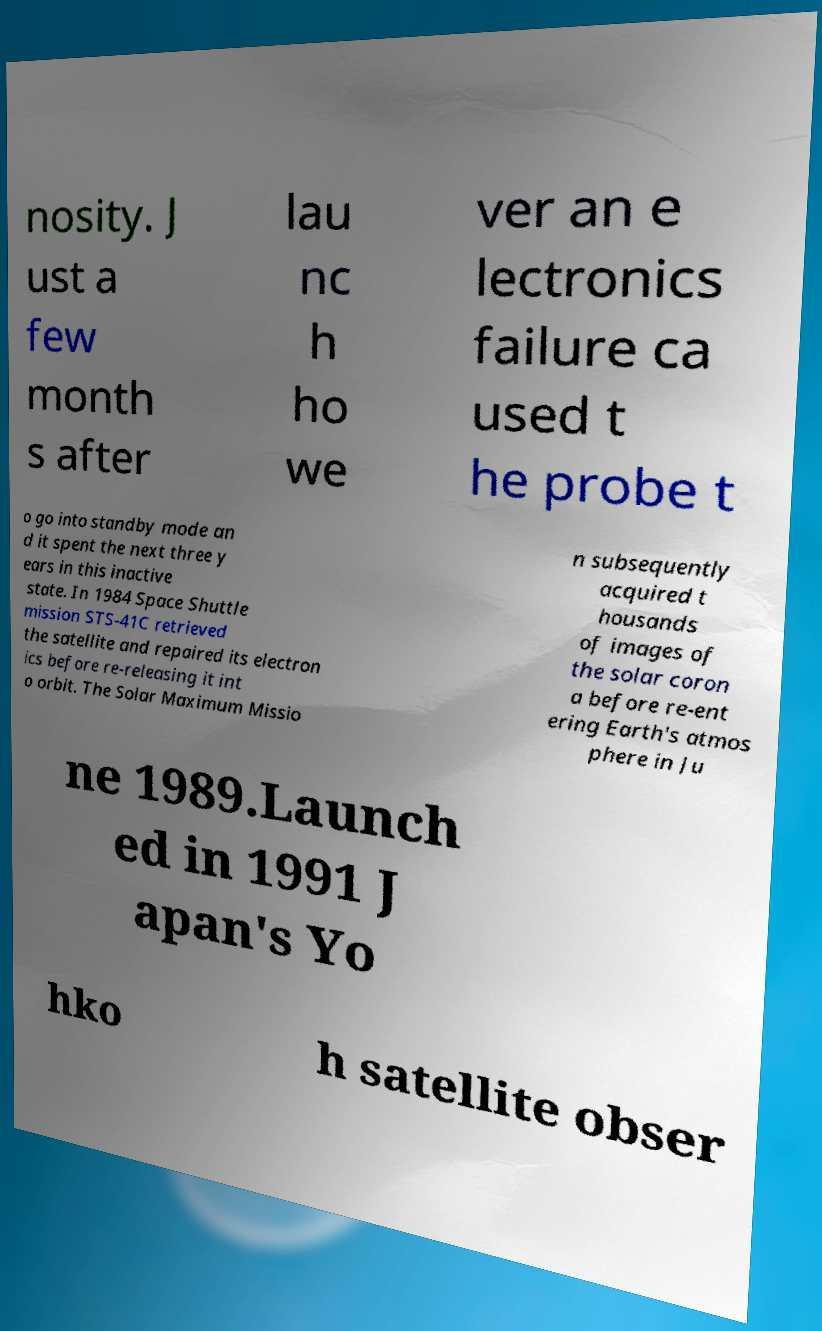I need the written content from this picture converted into text. Can you do that? nosity. J ust a few month s after lau nc h ho we ver an e lectronics failure ca used t he probe t o go into standby mode an d it spent the next three y ears in this inactive state. In 1984 Space Shuttle mission STS-41C retrieved the satellite and repaired its electron ics before re-releasing it int o orbit. The Solar Maximum Missio n subsequently acquired t housands of images of the solar coron a before re-ent ering Earth's atmos phere in Ju ne 1989.Launch ed in 1991 J apan's Yo hko h satellite obser 